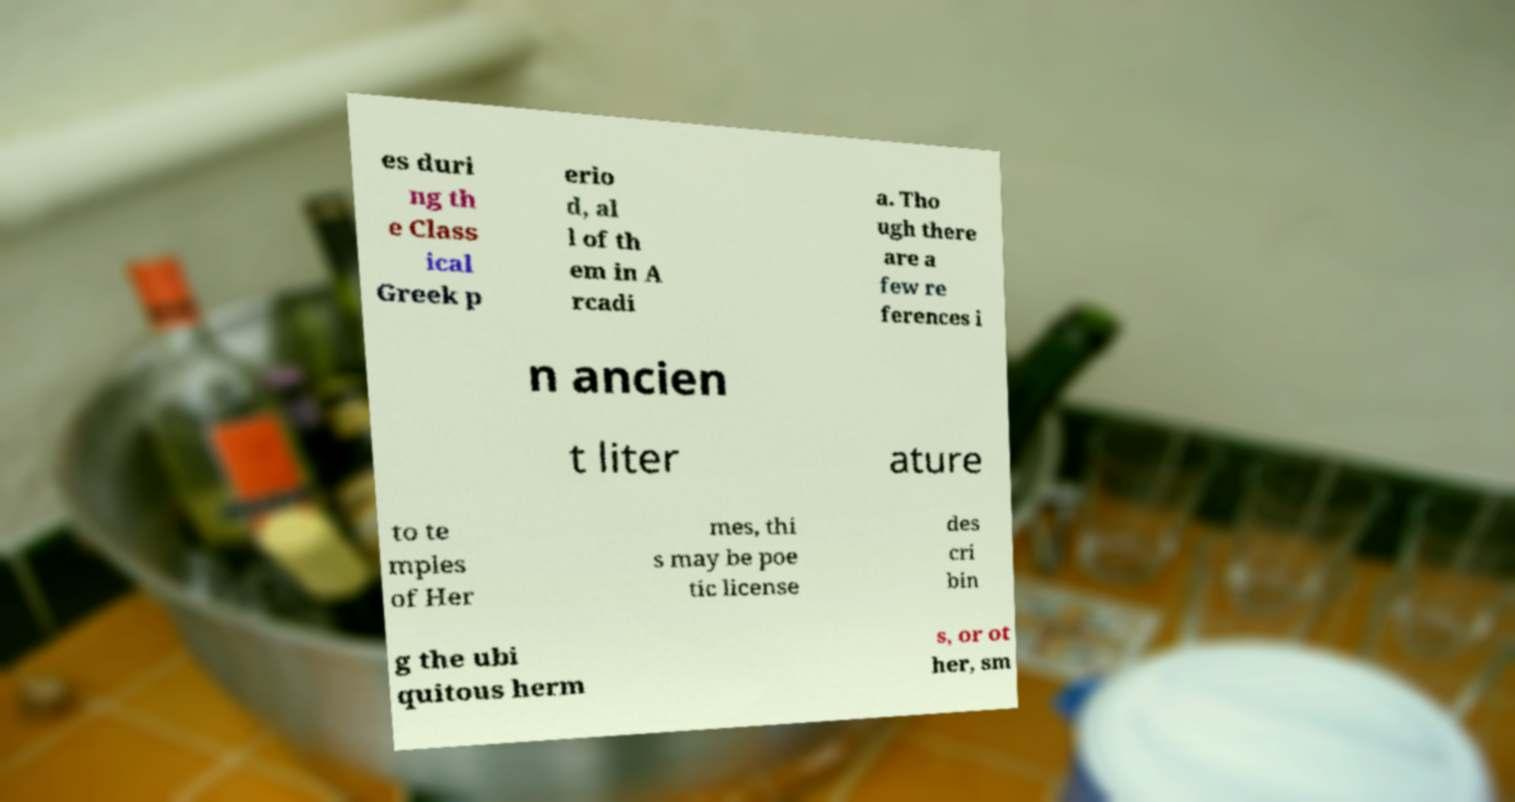Please read and relay the text visible in this image. What does it say? es duri ng th e Class ical Greek p erio d, al l of th em in A rcadi a. Tho ugh there are a few re ferences i n ancien t liter ature to te mples of Her mes, thi s may be poe tic license des cri bin g the ubi quitous herm s, or ot her, sm 